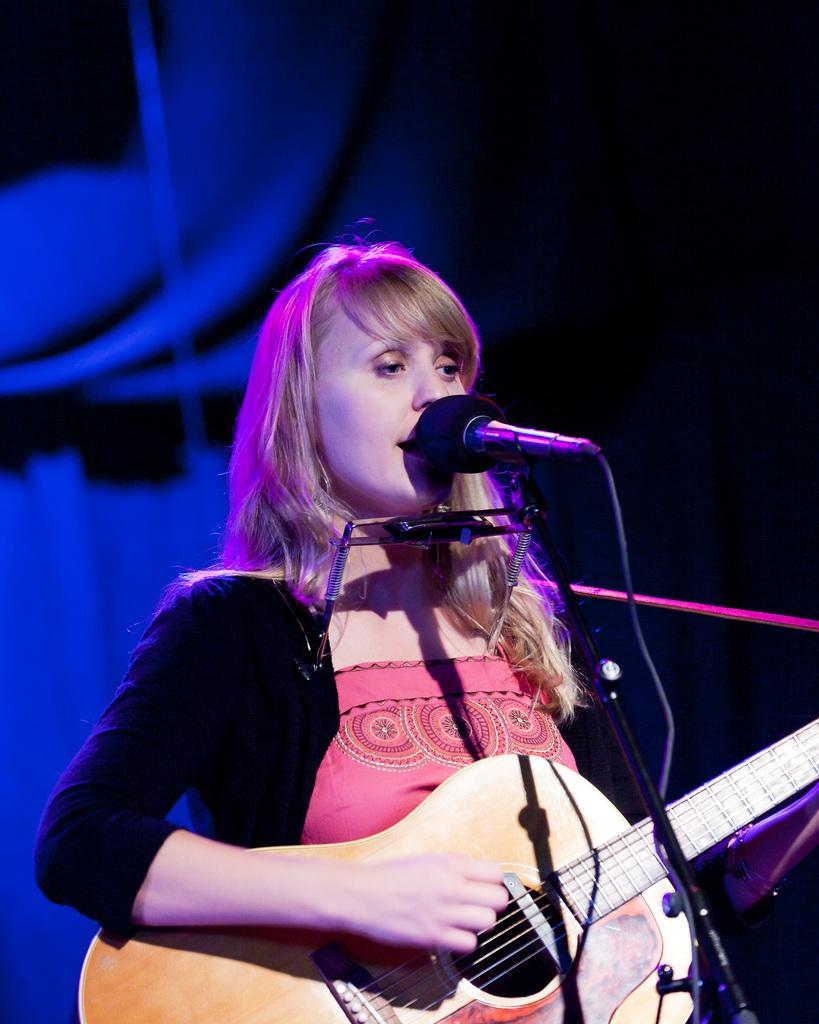Who is the main subject in the image? There is a woman in the image. What is the woman doing in the image? The woman is standing and holding a guitar. What other object is present in the image? There is a microphone in the image. What might the woman be doing with the microphone? The woman might be singing, as she is holding a guitar and there is a microphone present. Where is the scarecrow located in the image? There is no scarecrow present in the image. What type of market is visible in the image? There is no market visible in the image. 